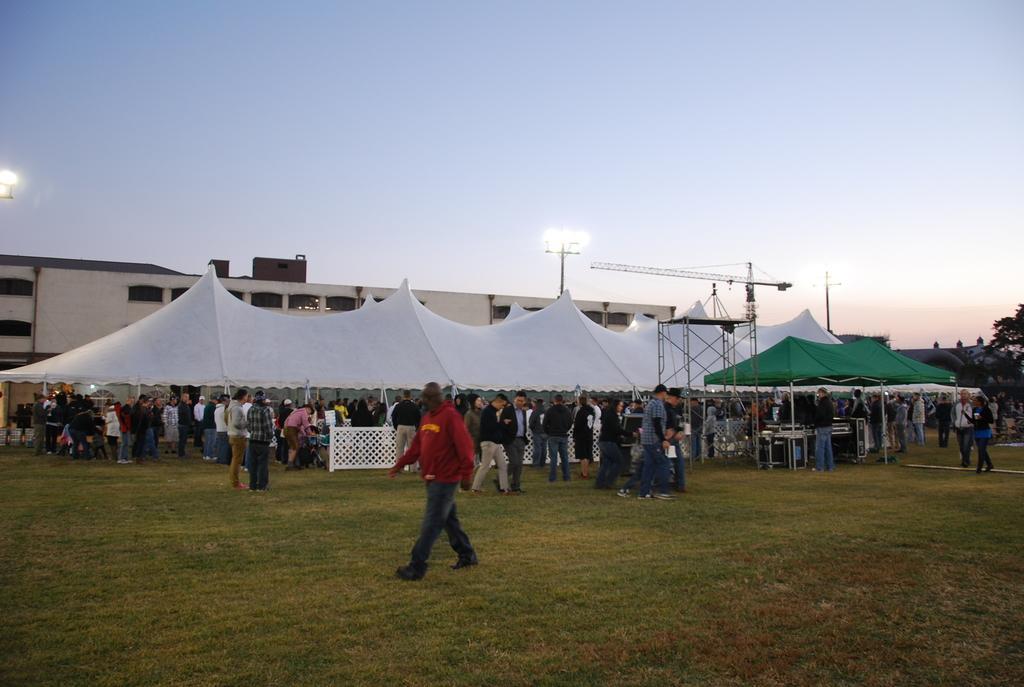How would you summarize this image in a sentence or two? In this image, we can see a group of people, tents, rods and few objects. Few people are walking on the grass. On the right side of the image, we can see a tree. Background we can see the walls, windows, pipes, poles, lights and sky. 